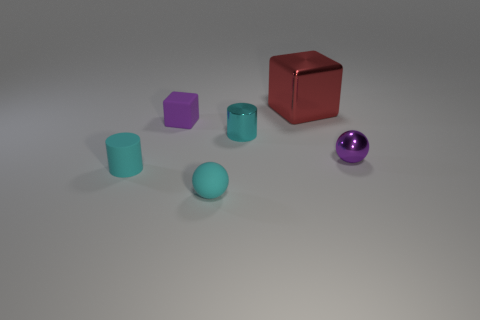Add 4 big gray matte things. How many objects exist? 10 Subtract all tiny cubes. Subtract all cyan matte cylinders. How many objects are left? 4 Add 4 tiny cyan matte balls. How many tiny cyan matte balls are left? 5 Add 1 tiny gray cylinders. How many tiny gray cylinders exist? 1 Subtract 0 blue cylinders. How many objects are left? 6 Subtract all balls. How many objects are left? 4 